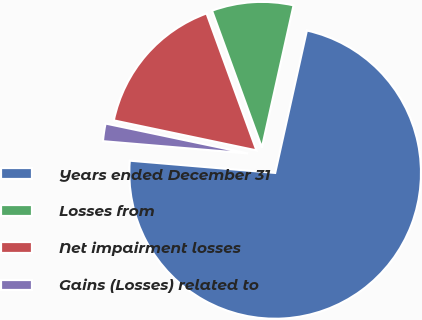<chart> <loc_0><loc_0><loc_500><loc_500><pie_chart><fcel>Years ended December 31<fcel>Losses from<fcel>Net impairment losses<fcel>Gains (Losses) related to<nl><fcel>72.85%<fcel>9.05%<fcel>16.14%<fcel>1.96%<nl></chart> 